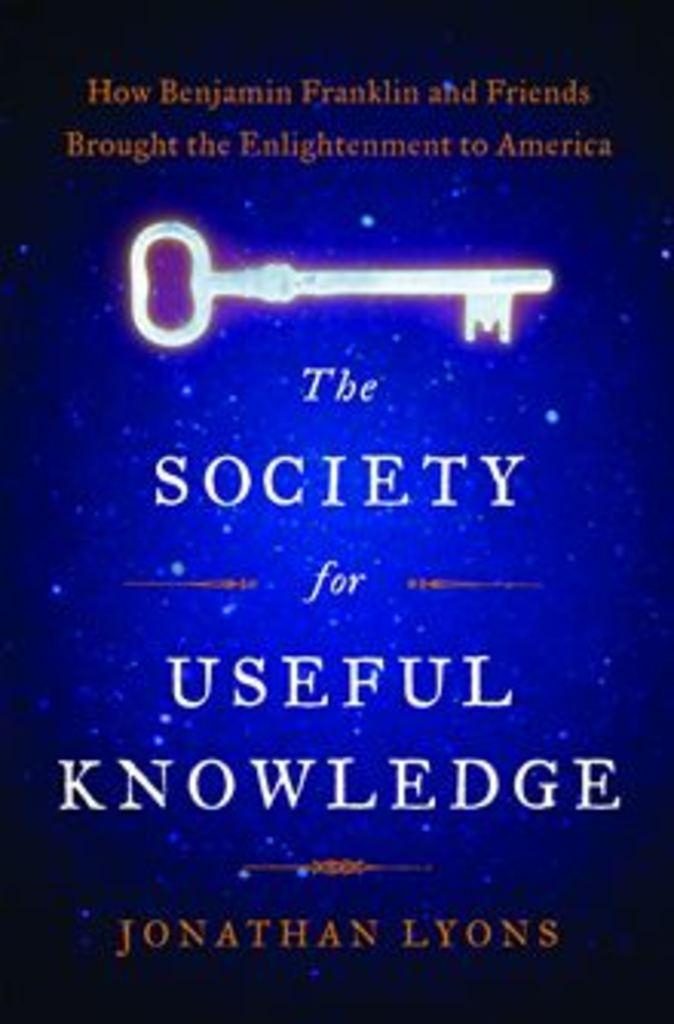<image>
Describe the image concisely. A book that is titled The Society for Useful Knowledge. 